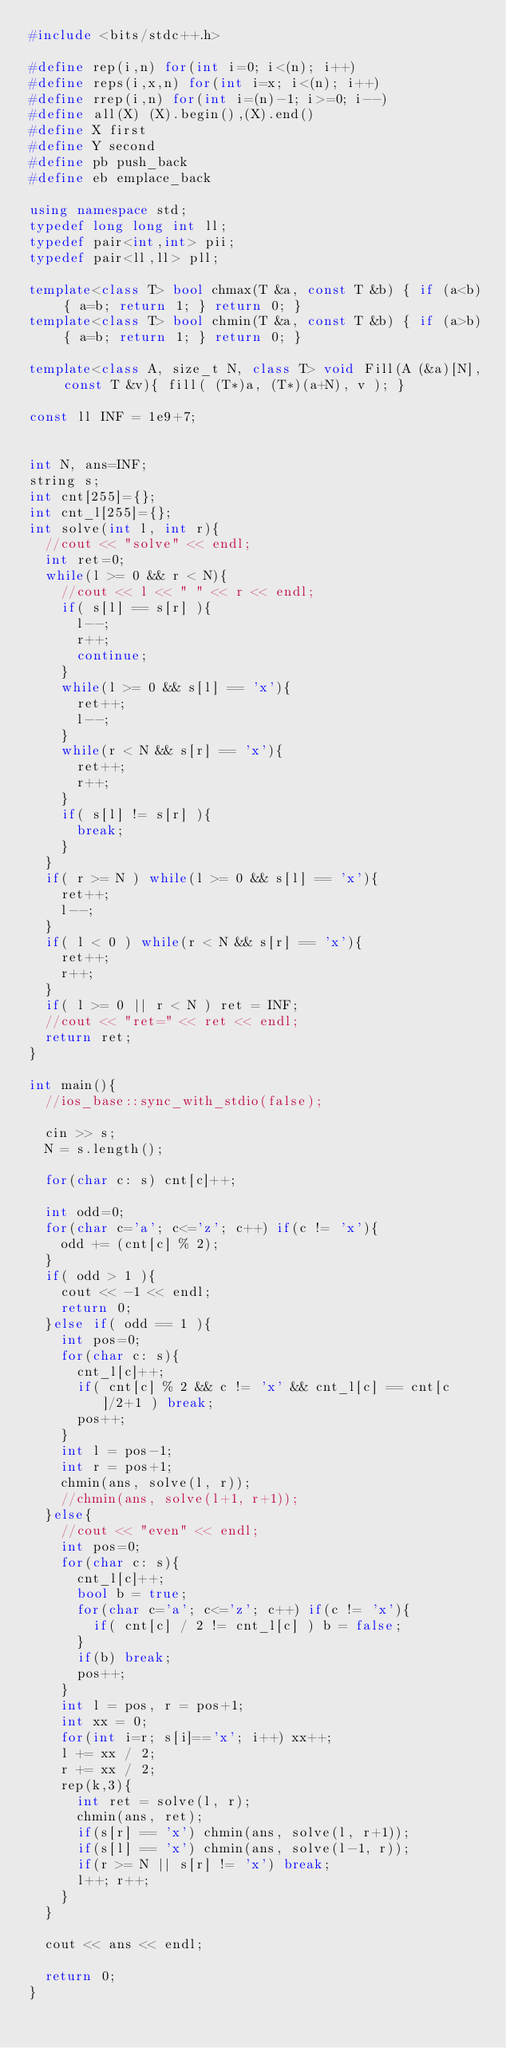<code> <loc_0><loc_0><loc_500><loc_500><_C++_>#include <bits/stdc++.h>

#define rep(i,n) for(int i=0; i<(n); i++)
#define reps(i,x,n) for(int i=x; i<(n); i++)
#define rrep(i,n) for(int i=(n)-1; i>=0; i--)
#define all(X) (X).begin(),(X).end()
#define X first
#define Y second
#define pb push_back
#define eb emplace_back

using namespace std;
typedef long long int ll;
typedef pair<int,int> pii;
typedef pair<ll,ll> pll;

template<class T> bool chmax(T &a, const T &b) { if (a<b) { a=b; return 1; } return 0; }
template<class T> bool chmin(T &a, const T &b) { if (a>b) { a=b; return 1; } return 0; }

template<class A, size_t N, class T> void Fill(A (&a)[N], const T &v){ fill( (T*)a, (T*)(a+N), v ); }

const ll INF = 1e9+7;


int N, ans=INF;
string s;
int cnt[255]={};
int cnt_l[255]={};
int solve(int l, int r){
	//cout << "solve" << endl;
	int ret=0;
	while(l >= 0 && r < N){
		//cout << l << " " << r << endl;
		if( s[l] == s[r] ){
			l--;
			r++;
			continue;
		}
		while(l >= 0 && s[l] == 'x'){
			ret++;
			l--;
		}
		while(r < N && s[r] == 'x'){
			ret++;
			r++;
		}
		if( s[l] != s[r] ){
			break;
		}
	}
	if( r >= N ) while(l >= 0 && s[l] == 'x'){
		ret++;
		l--;
	}
	if( l < 0 ) while(r < N && s[r] == 'x'){
		ret++;
		r++;
	}
	if( l >= 0 || r < N ) ret = INF;
	//cout << "ret=" << ret << endl;
	return ret;
}

int main(){
	//ios_base::sync_with_stdio(false);

	cin >> s;
	N = s.length();

	for(char c: s) cnt[c]++;

	int odd=0;
	for(char c='a'; c<='z'; c++) if(c != 'x'){
		odd += (cnt[c] % 2);
	}
	if( odd > 1 ){
		cout << -1 << endl;
		return 0;
	}else if( odd == 1 ){
		int pos=0;
		for(char c: s){
			cnt_l[c]++;
			if( cnt[c] % 2 && c != 'x' && cnt_l[c] == cnt[c]/2+1 ) break;
			pos++;
		}
		int l = pos-1;
		int r = pos+1;
		chmin(ans, solve(l, r));
		//chmin(ans, solve(l+1, r+1));
	}else{
		//cout << "even" << endl;
		int pos=0;
		for(char c: s){
			cnt_l[c]++;
			bool b = true;
			for(char c='a'; c<='z'; c++) if(c != 'x'){
				if( cnt[c] / 2 != cnt_l[c] ) b = false;
			}
			if(b) break;
			pos++;
		}
		int l = pos, r = pos+1;
		int xx = 0;
		for(int i=r; s[i]=='x'; i++) xx++;
		l += xx / 2;
		r += xx / 2;
		rep(k,3){
			int ret = solve(l, r);
			chmin(ans, ret);
			if(s[r] == 'x') chmin(ans, solve(l, r+1));
			if(s[l] == 'x') chmin(ans, solve(l-1, r));
			if(r >= N || s[r] != 'x') break;
			l++; r++;
		}
	}

	cout << ans << endl;

	return 0;
}
</code> 